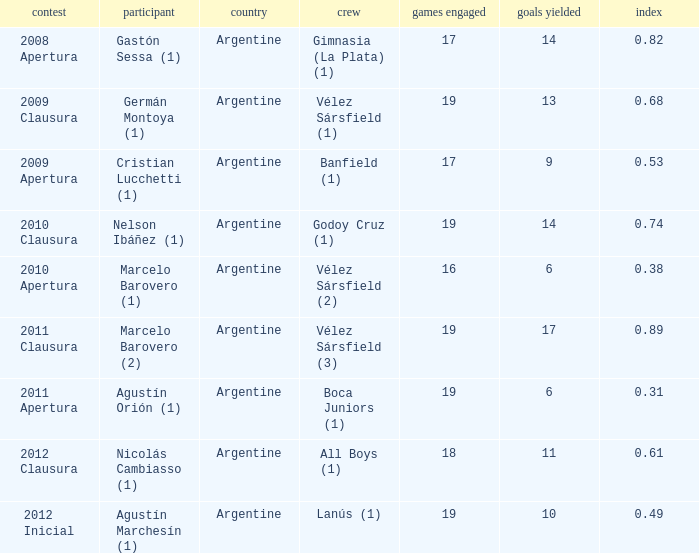How many nationalities are there for the 2011 apertura? 1.0. 